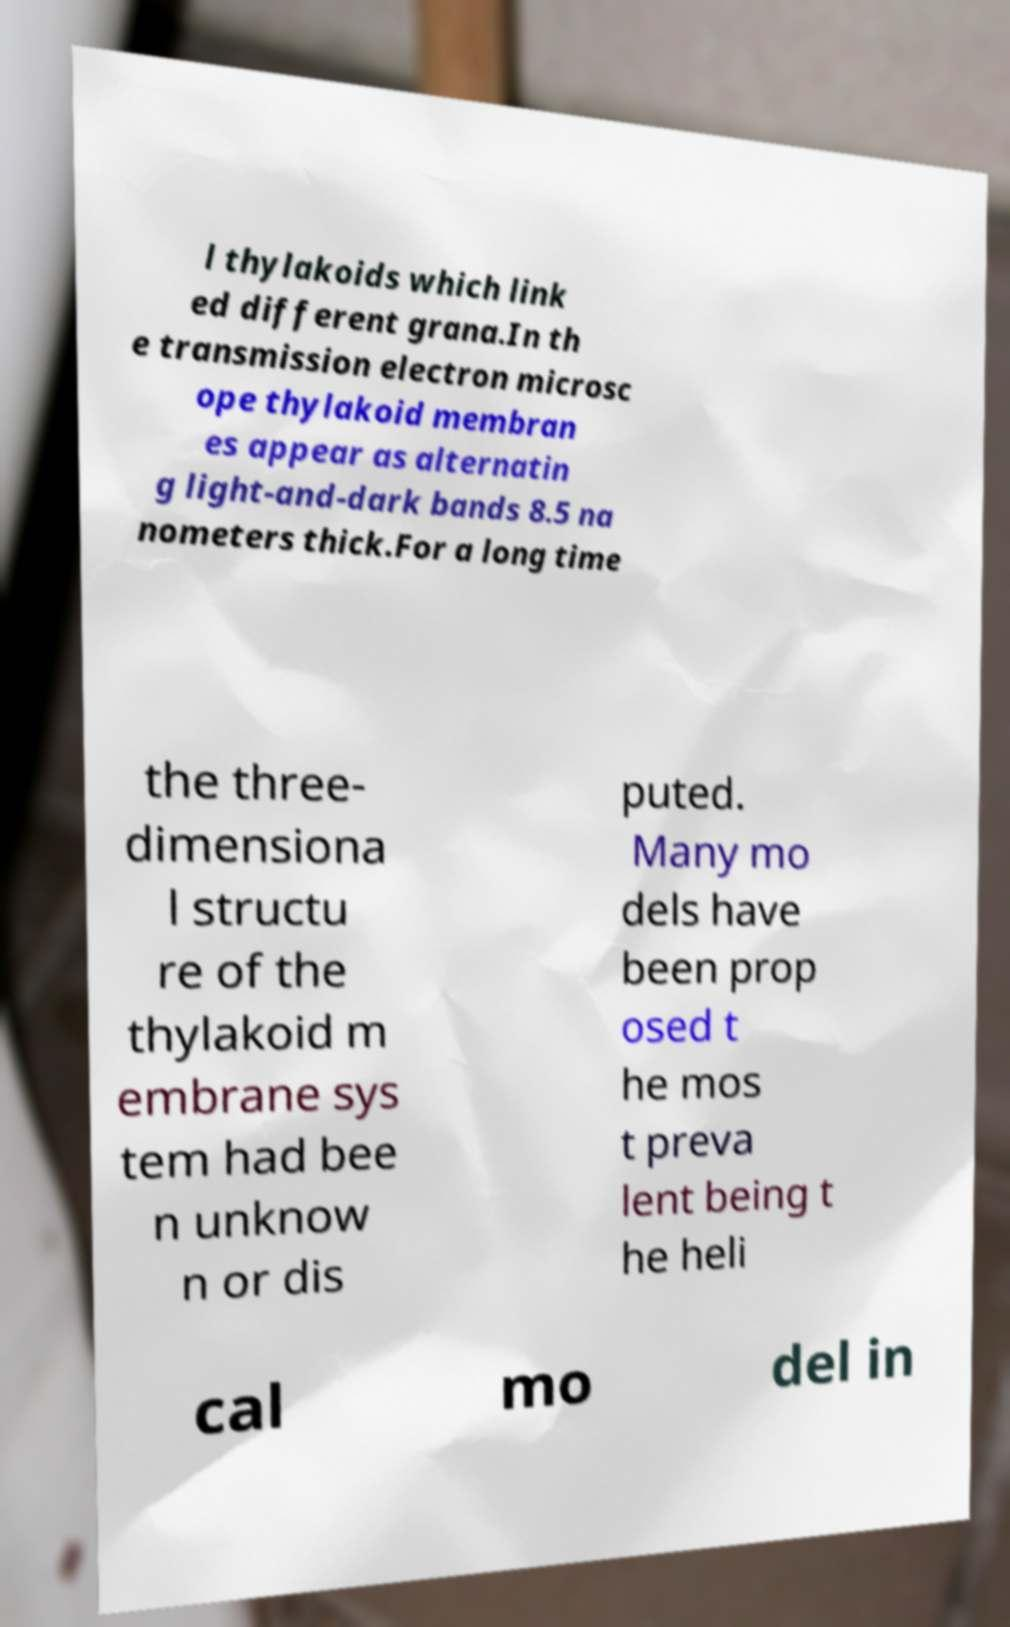Can you accurately transcribe the text from the provided image for me? l thylakoids which link ed different grana.In th e transmission electron microsc ope thylakoid membran es appear as alternatin g light-and-dark bands 8.5 na nometers thick.For a long time the three- dimensiona l structu re of the thylakoid m embrane sys tem had bee n unknow n or dis puted. Many mo dels have been prop osed t he mos t preva lent being t he heli cal mo del in 